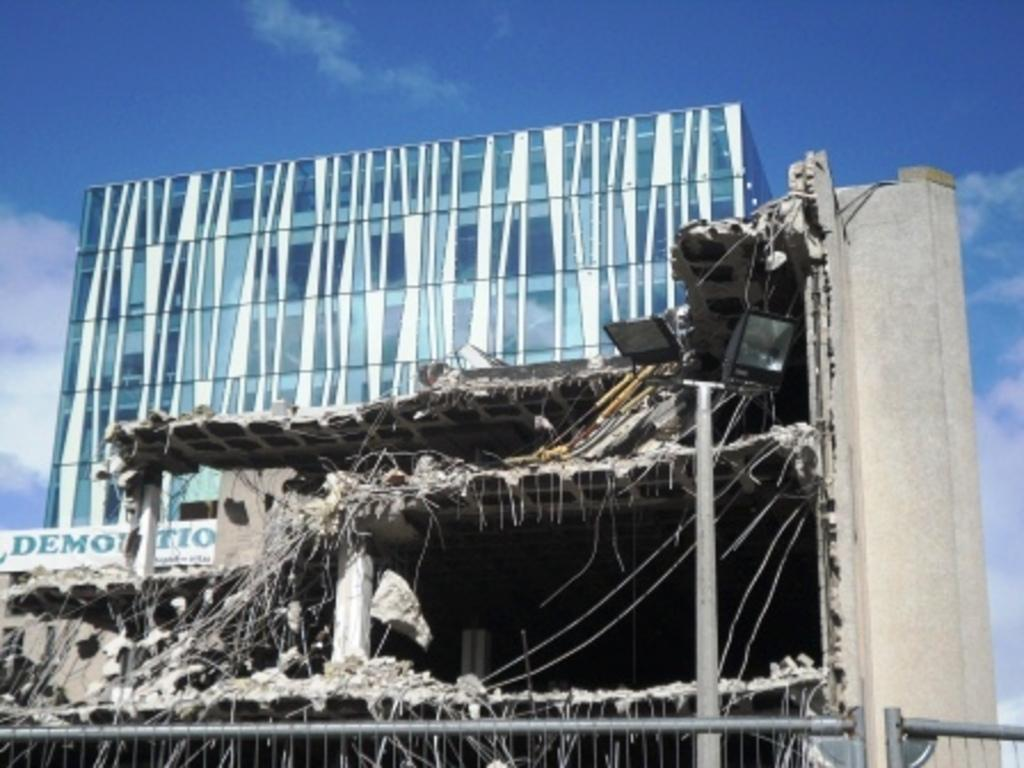What can be seen in the sky in the image? The sky is visible in the image, and there are clouds in the sky. What type of structures are present in the image? There are buildings in the image. What object in the image has text on it? There is a board in the image, and there is text on the board. What type of illumination is present in the image? There are lights in the image. What vertical object can be seen in the image? There is a pole in the image. What color of paint is used on the cable in the image? There is no cable present in the image, so the color of paint cannot be determined. 